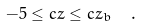Convert formula to latex. <formula><loc_0><loc_0><loc_500><loc_500>- 5 \leq c z \leq c z _ { b } \ \ .</formula> 